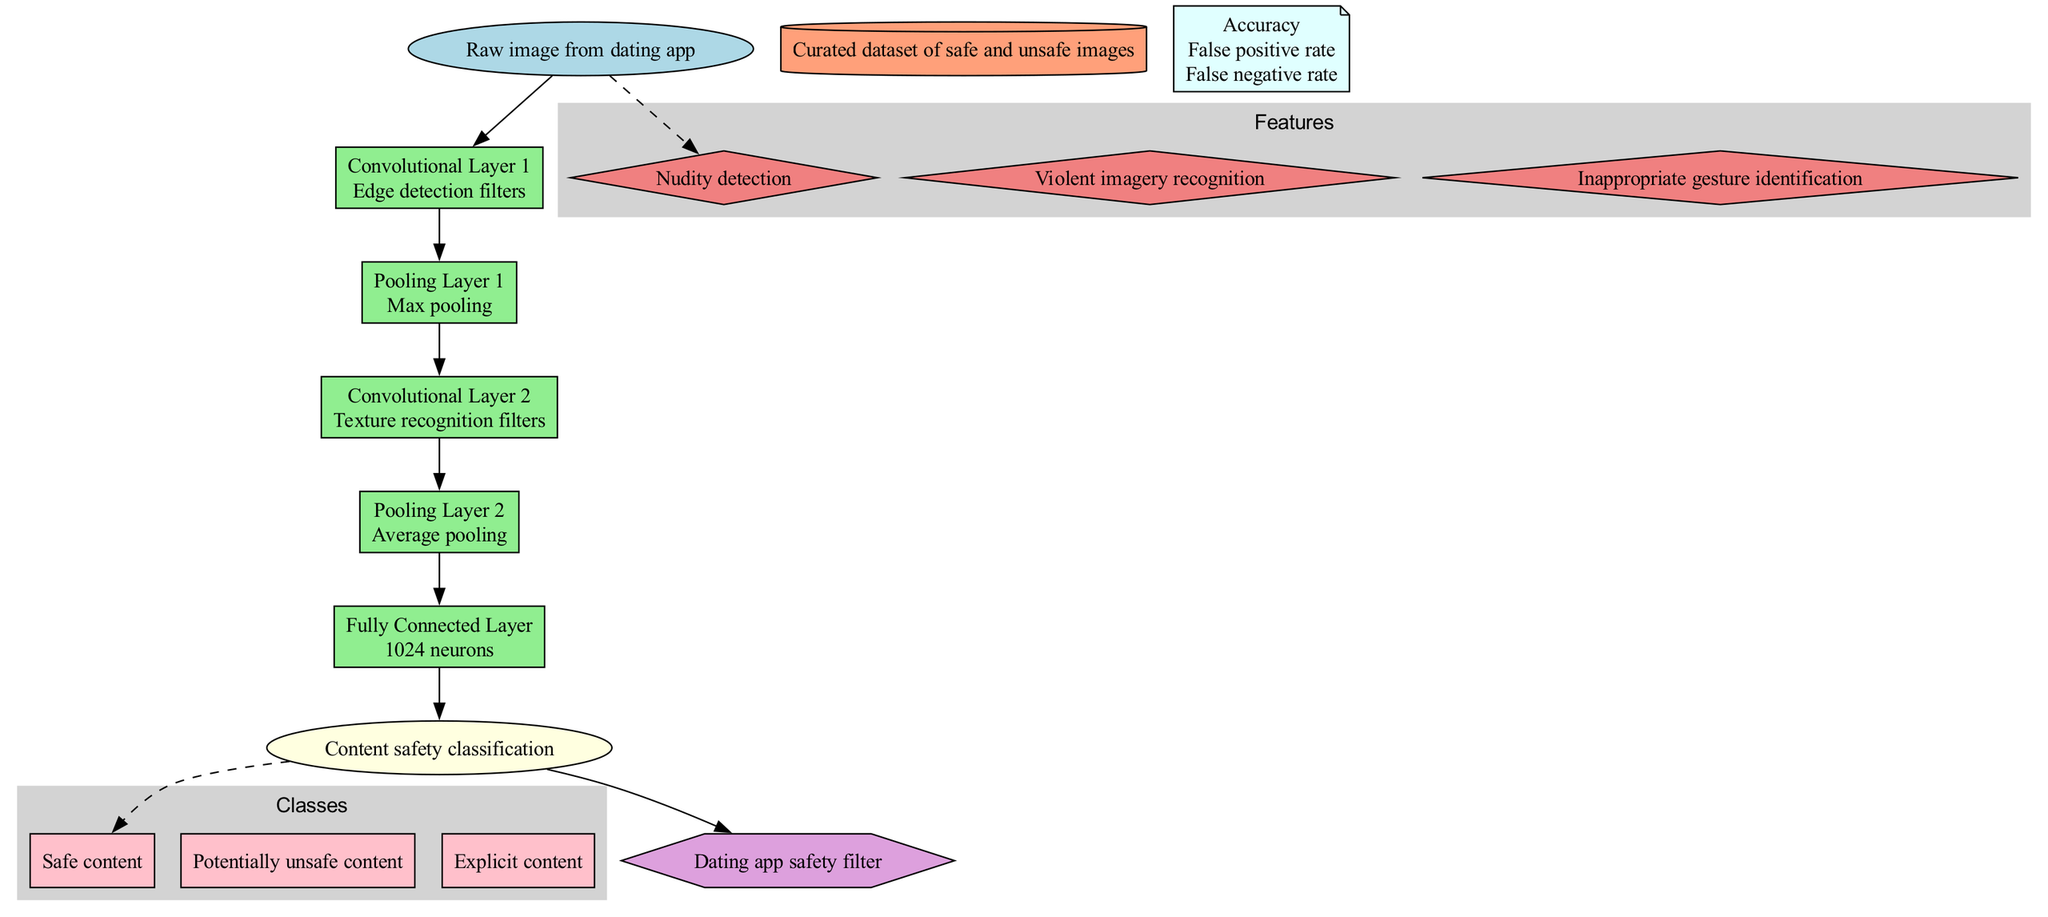What is the input of the diagram? The input node of the diagram clearly states that it is a "Raw image from dating app." This is the starting point of the convolutional neural network (CNN) architecture.
Answer: Raw image from dating app How many layers are there in the architecture? The diagram includes a total of five layers, which are listed sequentially: two convolutional layers, two pooling layers, and one fully connected layer.
Answer: 5 layers What type of pooling operation is used in the second pooling layer? Looking at the layer details in the diagram, the second pooling layer specifically states that it utilizes "Average pooling" as its operation.
Answer: Average pooling What is the number of neurons in the fully connected layer? The fully connected layer is specified to have "1024 neurons," as mentioned directly in the layer's description within the diagram.
Answer: 1024 neurons What are the three classes of content in the output? According to the output section of the diagram, the three classes of content are "Safe content," "Potentially unsafe content," and "Explicit content."
Answer: Safe content, Potentially unsafe content, Explicit content Explain how the training data influences the output classification. The training data is a "Curated dataset of safe and unsafe images" which the model learns from. This learning process helps the CNN to identify and classify the content in incoming images based on features learned during training, ultimately leading to the correct classification in the output.
Answer: By providing labeled examples, it trains the model to recognize patterns In which layer is "Edge detection filters" utilized? The "Edge detection filters" are explicitly indicated in the first convolutional layer of the architecture. This layer is focused on extracting basic features such as edges from the raw input image.
Answer: Convolutional Layer 1 What is the purpose of the integration node in the diagram? The integration node is described as the "Dating app safety filter," indicating that it serves to implement the classification results into the dating app to filter unsafe content based on the model's predictions.
Answer: Dating app safety filter How many features are identified in the architecture? The diagram outlines three distinct features that the CNN identifies: "Nudity detection," "Violent imagery recognition," and "Inappropriate gesture identification." Therefore, we can conclude that there are three features outlined.
Answer: 3 features 